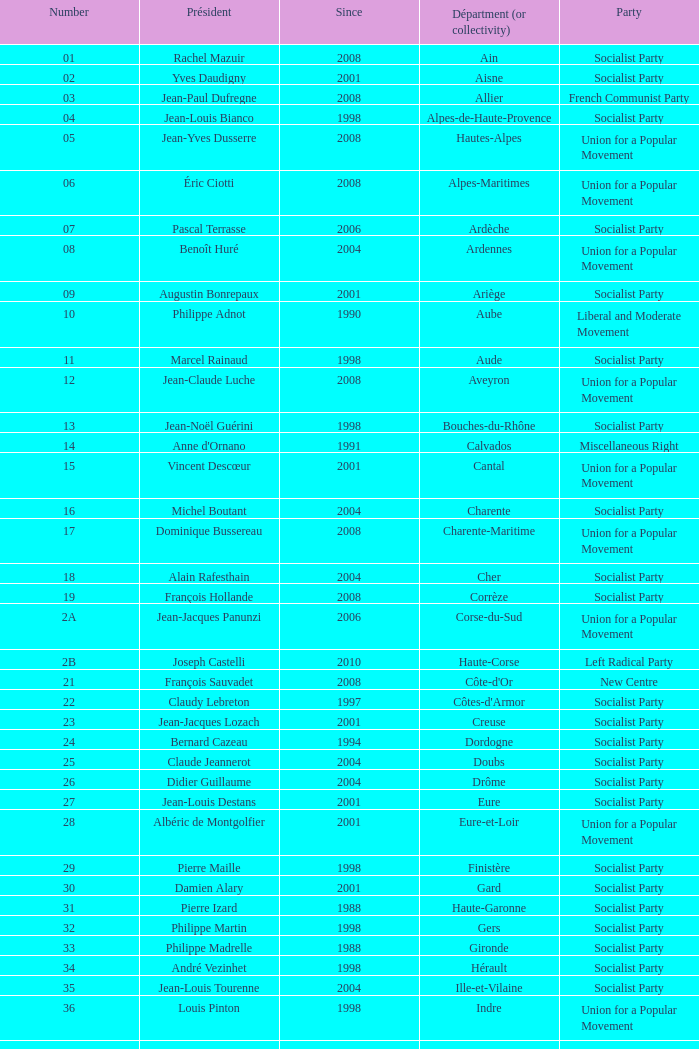Could you help me parse every detail presented in this table? {'header': ['Number', 'Président', 'Since', 'Départment (or collectivity)', 'Party'], 'rows': [['01', 'Rachel Mazuir', '2008', 'Ain', 'Socialist Party'], ['02', 'Yves Daudigny', '2001', 'Aisne', 'Socialist Party'], ['03', 'Jean-Paul Dufregne', '2008', 'Allier', 'French Communist Party'], ['04', 'Jean-Louis Bianco', '1998', 'Alpes-de-Haute-Provence', 'Socialist Party'], ['05', 'Jean-Yves Dusserre', '2008', 'Hautes-Alpes', 'Union for a Popular Movement'], ['06', 'Éric Ciotti', '2008', 'Alpes-Maritimes', 'Union for a Popular Movement'], ['07', 'Pascal Terrasse', '2006', 'Ardèche', 'Socialist Party'], ['08', 'Benoît Huré', '2004', 'Ardennes', 'Union for a Popular Movement'], ['09', 'Augustin Bonrepaux', '2001', 'Ariège', 'Socialist Party'], ['10', 'Philippe Adnot', '1990', 'Aube', 'Liberal and Moderate Movement'], ['11', 'Marcel Rainaud', '1998', 'Aude', 'Socialist Party'], ['12', 'Jean-Claude Luche', '2008', 'Aveyron', 'Union for a Popular Movement'], ['13', 'Jean-Noël Guérini', '1998', 'Bouches-du-Rhône', 'Socialist Party'], ['14', "Anne d'Ornano", '1991', 'Calvados', 'Miscellaneous Right'], ['15', 'Vincent Descœur', '2001', 'Cantal', 'Union for a Popular Movement'], ['16', 'Michel Boutant', '2004', 'Charente', 'Socialist Party'], ['17', 'Dominique Bussereau', '2008', 'Charente-Maritime', 'Union for a Popular Movement'], ['18', 'Alain Rafesthain', '2004', 'Cher', 'Socialist Party'], ['19', 'François Hollande', '2008', 'Corrèze', 'Socialist Party'], ['2A', 'Jean-Jacques Panunzi', '2006', 'Corse-du-Sud', 'Union for a Popular Movement'], ['2B', 'Joseph Castelli', '2010', 'Haute-Corse', 'Left Radical Party'], ['21', 'François Sauvadet', '2008', "Côte-d'Or", 'New Centre'], ['22', 'Claudy Lebreton', '1997', "Côtes-d'Armor", 'Socialist Party'], ['23', 'Jean-Jacques Lozach', '2001', 'Creuse', 'Socialist Party'], ['24', 'Bernard Cazeau', '1994', 'Dordogne', 'Socialist Party'], ['25', 'Claude Jeannerot', '2004', 'Doubs', 'Socialist Party'], ['26', 'Didier Guillaume', '2004', 'Drôme', 'Socialist Party'], ['27', 'Jean-Louis Destans', '2001', 'Eure', 'Socialist Party'], ['28', 'Albéric de Montgolfier', '2001', 'Eure-et-Loir', 'Union for a Popular Movement'], ['29', 'Pierre Maille', '1998', 'Finistère', 'Socialist Party'], ['30', 'Damien Alary', '2001', 'Gard', 'Socialist Party'], ['31', 'Pierre Izard', '1988', 'Haute-Garonne', 'Socialist Party'], ['32', 'Philippe Martin', '1998', 'Gers', 'Socialist Party'], ['33', 'Philippe Madrelle', '1988', 'Gironde', 'Socialist Party'], ['34', 'André Vezinhet', '1998', 'Hérault', 'Socialist Party'], ['35', 'Jean-Louis Tourenne', '2004', 'Ille-et-Vilaine', 'Socialist Party'], ['36', 'Louis Pinton', '1998', 'Indre', 'Union for a Popular Movement'], ['37', 'Claude Roiron', '2008', 'Indre-et-Loire', 'Socialist Party'], ['38', 'André Vallini', '2001', 'Isère', 'Socialist Party'], ['39', 'Jean Raquin', '2008', 'Jura', 'Miscellaneous Right'], ['40', 'Henri Emmanuelli', '1982', 'Landes', 'Socialist Party'], ['41', 'Maurice Leroy', '2004', 'Loir-et-Cher', 'New Centre'], ['42', 'Bernard Bonne', '2008', 'Loire', 'Union for a Popular Movement'], ['43', 'Gérard Roche', '2004', 'Haute-Loire', 'Union for a Popular Movement'], ['44', 'Patrick Mareschal', '2004', 'Loire-Atlantique', 'Socialist Party'], ['45', 'Éric Doligé', '1994', 'Loiret', 'Union for a Popular Movement'], ['46', 'Gérard Miquel', '2004', 'Lot', 'Socialist Party'], ['47', 'Pierre Camani', '2008', 'Lot-et-Garonne', 'Socialist Party'], ['48', 'Jean-Paul Pourquier', '2004', 'Lozère', 'Union for a Popular Movement'], ['49', 'Christophe Béchu', '2004', 'Maine-et-Loire', 'Union for a Popular Movement'], ['50', 'Jean-François Le Grand', '1998', 'Manche', 'Union for a Popular Movement'], ['51', 'René-Paul Savary', '2003', 'Marne', 'Union for a Popular Movement'], ['52', 'Bruno Sido', '1998', 'Haute-Marne', 'Union for a Popular Movement'], ['53', 'Jean Arthuis', '1992', 'Mayenne', 'Miscellaneous Centre'], ['54', 'Michel Dinet', '1998', 'Meurthe-et-Moselle', 'Socialist Party'], ['55', 'Christian Namy', '2004', 'Meuse', 'Miscellaneous Right'], ['56', 'Joseph-François Kerguéris', '2004', 'Morbihan', 'Democratic Movement'], ['57', 'Philippe Leroy', '1992', 'Moselle', 'Union for a Popular Movement'], ['58', 'Marcel Charmant', '2001', 'Nièvre', 'Socialist Party'], ['59', 'Patrick Kanner', '1998', 'Nord', 'Socialist Party'], ['60', 'Yves Rome', '2004', 'Oise', 'Socialist Party'], ['61', 'Alain Lambert', '2007', 'Orne', 'Union for a Popular Movement'], ['62', 'Dominique Dupilet', '2004', 'Pas-de-Calais', 'Socialist Party'], ['63', 'Jean-Yves Gouttebel', '2004', 'Puy-de-Dôme', 'Socialist Party'], ['64', 'Jean Castaings', '2008', 'Pyrénées-Atlantiques', 'Union for a Popular Movement'], ['65', 'Josette Durrieu', '2008', 'Hautes-Pyrénées', 'Socialist Party'], ['66', 'Christian Bourquin', '1998', 'Pyrénées-Orientales', 'Socialist Party'], ['67', 'Guy-Dominique Kennel', '2008', 'Bas-Rhin', 'Union for a Popular Movement'], ['68', 'Charles Buttner', '2004', 'Haut-Rhin', 'Union for a Popular Movement'], ['69', 'Michel Mercier', '1990', 'Rhône', 'Miscellaneous Centre'], ['70', 'Yves Krattinger', '2002', 'Haute-Saône', 'Socialist Party'], ['71', 'Arnaud Montebourg', '2008', 'Saône-et-Loire', 'Socialist Party'], ['72', 'Roland du Luart', '1998', 'Sarthe', 'Union for a Popular Movement'], ['73', 'Hervé Gaymard', '2008', 'Savoie', 'Union for a Popular Movement'], ['74', 'Christian Monteil', '2008', 'Haute-Savoie', 'Miscellaneous Right'], ['75', 'Bertrand Delanoë', '2001', 'Paris', 'Socialist Party'], ['76', 'Didier Marie', '2004', 'Seine-Maritime', 'Socialist Party'], ['77', 'Vincent Eblé', '2004', 'Seine-et-Marne', 'Socialist Party'], ['78', 'Pierre Bédier', '2005', 'Yvelines', 'Union for a Popular Movement'], ['79', 'Éric Gautier', '2008', 'Deux-Sèvres', 'Socialist Party'], ['80', 'Christian Manable', '2008', 'Somme', 'Socialist Party'], ['81', 'Thierry Carcenac', '1991', 'Tarn', 'Socialist Party'], ['82', 'Jean-Michel Baylet', '1986', 'Tarn-et-Garonne', 'Left Radical Party'], ['83', 'Horace Lanfranchi', '2002', 'Var', 'Union for a Popular Movement'], ['84', 'Claude Haut', '2001', 'Vaucluse', 'Socialist Party'], ['85', 'Philippe de Villiers', '1988', 'Vendée', 'Movement for France'], ['86', 'Claude Bertaud', '2008', 'Vienne', 'Union for a Popular Movement'], ['87', 'Marie-Françoise Pérol-Dumont', '2004', 'Haute-Vienne', 'Socialist Party'], ['88', 'Christian Poncelet', '1976', 'Vosges', 'Union for a Popular Movement'], ['89', 'Jean-Marie Rolland', '2008', 'Yonne', 'Union for a Popular Movement'], ['90', 'Yves Ackermann', '2004', 'Territoire de Belfort', 'Socialist Party'], ['91', 'Michel Berson', '1998', 'Essonne', 'Socialist Party'], ['92', 'Patrick Devedjian', '2007', 'Hauts-de-Seine', 'Union for a Popular Movement'], ['93', 'Claude Bartolone', '2008', 'Seine-Saint-Denis', 'Socialist Party'], ['94', 'Christian Favier', '2001', 'Val-de-Marne', 'French Communist Party'], ['95', 'Arnaud Bazin', '2011', 'Val-d’Oise', 'Union for a Popular Movement'], ['971', 'Jacques Gillot', '2001', 'Guadeloupe', 'United Guadeloupe, Socialism and Realities'], ['972', 'Claude Lise', '1992', 'Martinique', 'Martinican Democratic Rally'], ['973', 'Alain Tien-Liong', '2008', 'Guyane', 'Miscellaneous Left'], ['974', 'Nassimah Dindar', '2004', 'Réunion', 'Union for a Popular Movement'], ['975', 'Stéphane Artano', '2006', 'Saint-Pierre-et-Miquelon (overseas collect.)', 'Archipelago Tomorrow'], ['976', 'Ahmed Attoumani Douchina', '2008', 'Mayotte (overseas collect.)', 'Union for a Popular Movement']]} Who is the president from the Union for a Popular Movement party that represents the Hautes-Alpes department? Jean-Yves Dusserre. 